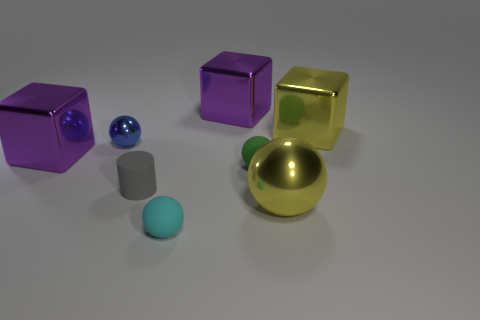There is another large ball that is the same material as the blue sphere; what is its color?
Make the answer very short. Yellow. What number of objects are cyan matte things to the right of the blue thing or small blue balls?
Provide a short and direct response. 2. There is a purple metallic block behind the small metal thing; how big is it?
Your answer should be compact. Large. There is a cylinder; is it the same size as the metal sphere that is on the left side of the tiny gray rubber thing?
Offer a terse response. Yes. There is a block behind the yellow thing behind the matte cylinder; what is its color?
Ensure brevity in your answer.  Purple. How many other objects are the same color as the big metallic ball?
Give a very brief answer. 1. The yellow ball is what size?
Offer a terse response. Large. Is the number of small things to the left of the big yellow cube greater than the number of small cyan matte balls left of the small metal thing?
Provide a short and direct response. Yes. There is a rubber sphere to the left of the green sphere; how many big purple blocks are right of it?
Your response must be concise. 1. There is a yellow metal object in front of the small blue object; is it the same shape as the tiny cyan rubber thing?
Ensure brevity in your answer.  Yes. 